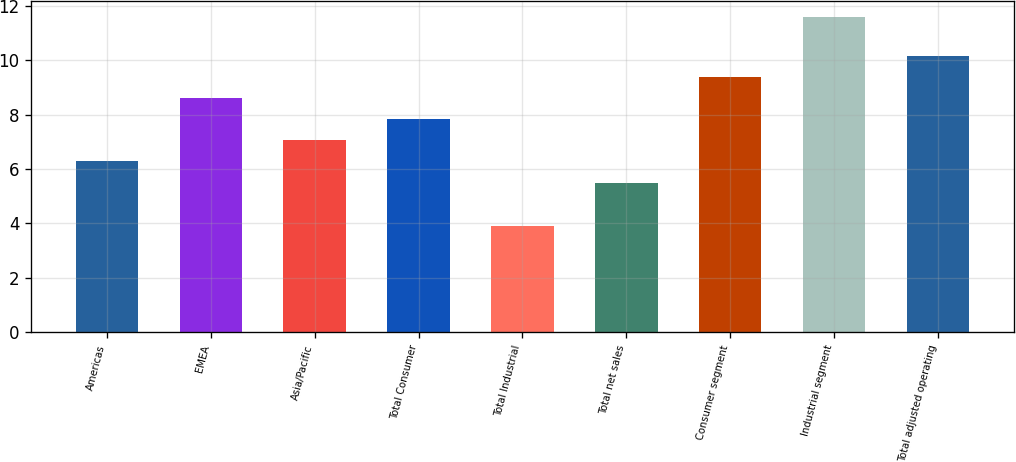Convert chart to OTSL. <chart><loc_0><loc_0><loc_500><loc_500><bar_chart><fcel>Americas<fcel>EMEA<fcel>Asia/Pacific<fcel>Total Consumer<fcel>Total Industrial<fcel>Total net sales<fcel>Consumer segment<fcel>Industrial segment<fcel>Total adjusted operating<nl><fcel>6.3<fcel>8.61<fcel>7.07<fcel>7.84<fcel>3.9<fcel>5.5<fcel>9.38<fcel>11.6<fcel>10.15<nl></chart> 